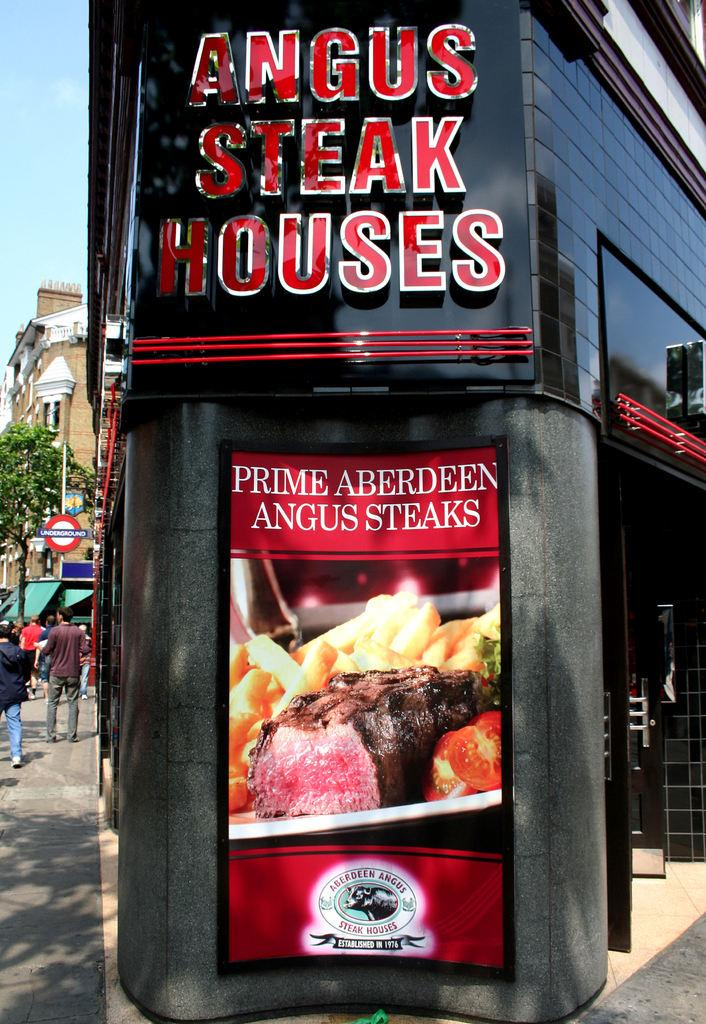<image>
Write a terse but informative summary of the picture. a sign outside of a building that says 'angus steak houses' in red and white 